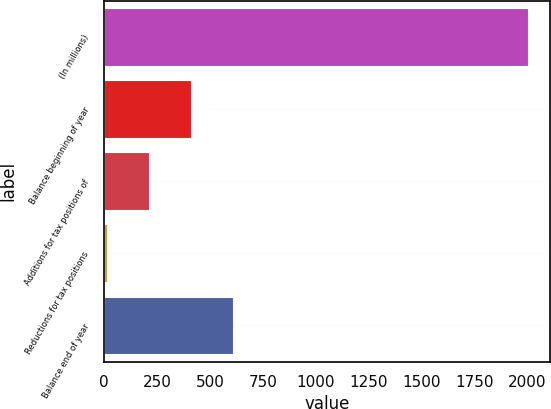<chart> <loc_0><loc_0><loc_500><loc_500><bar_chart><fcel>(In millions)<fcel>Balance beginning of year<fcel>Additions for tax positions of<fcel>Reductions for tax positions<fcel>Balance end of year<nl><fcel>2007<fcel>410.2<fcel>210.6<fcel>11<fcel>609.8<nl></chart> 